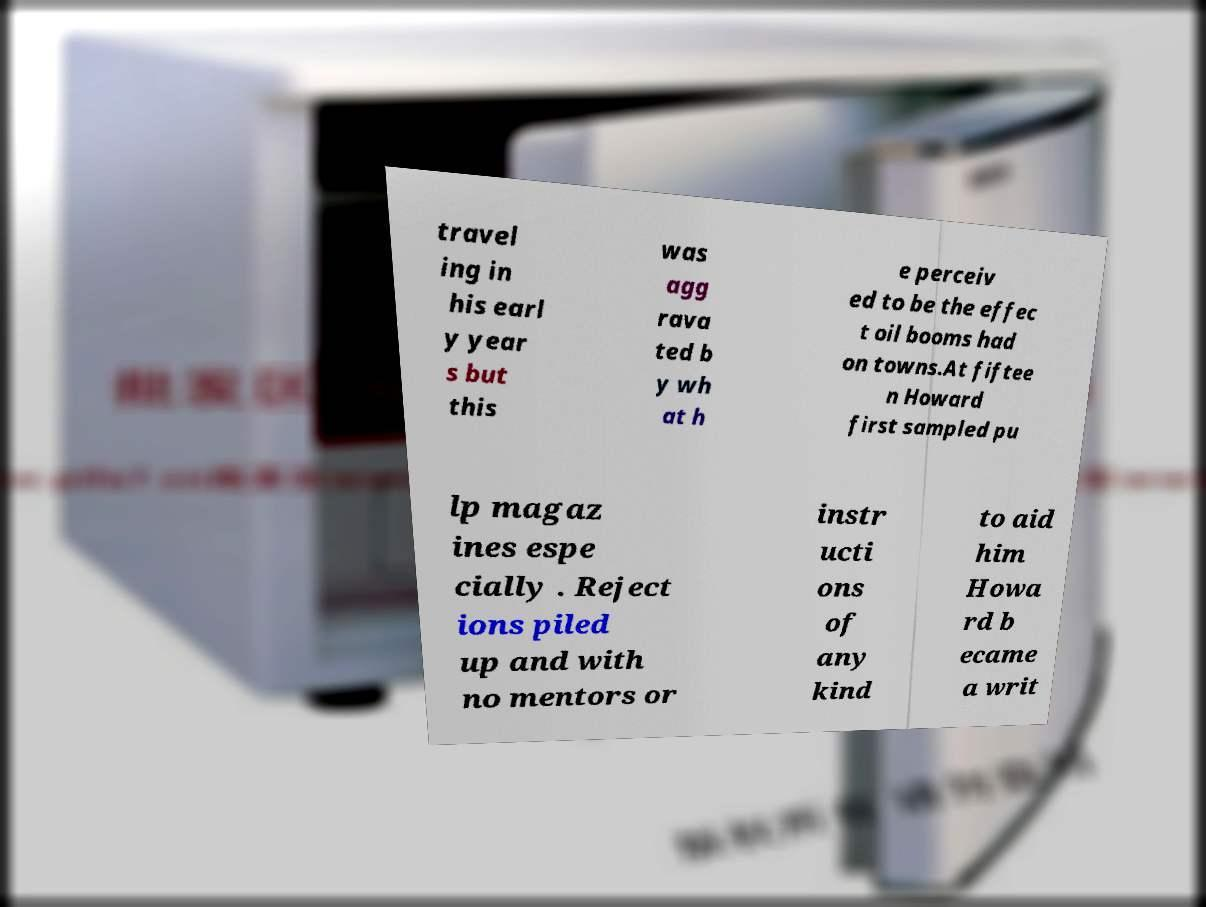For documentation purposes, I need the text within this image transcribed. Could you provide that? travel ing in his earl y year s but this was agg rava ted b y wh at h e perceiv ed to be the effec t oil booms had on towns.At fiftee n Howard first sampled pu lp magaz ines espe cially . Reject ions piled up and with no mentors or instr ucti ons of any kind to aid him Howa rd b ecame a writ 